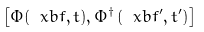Convert formula to latex. <formula><loc_0><loc_0><loc_500><loc_500>\left [ \Phi ( \ x b f , t ) , \Phi ^ { \dagger } \left ( \ x b f ^ { \prime } , t ^ { \prime } \right ) \right ]</formula> 